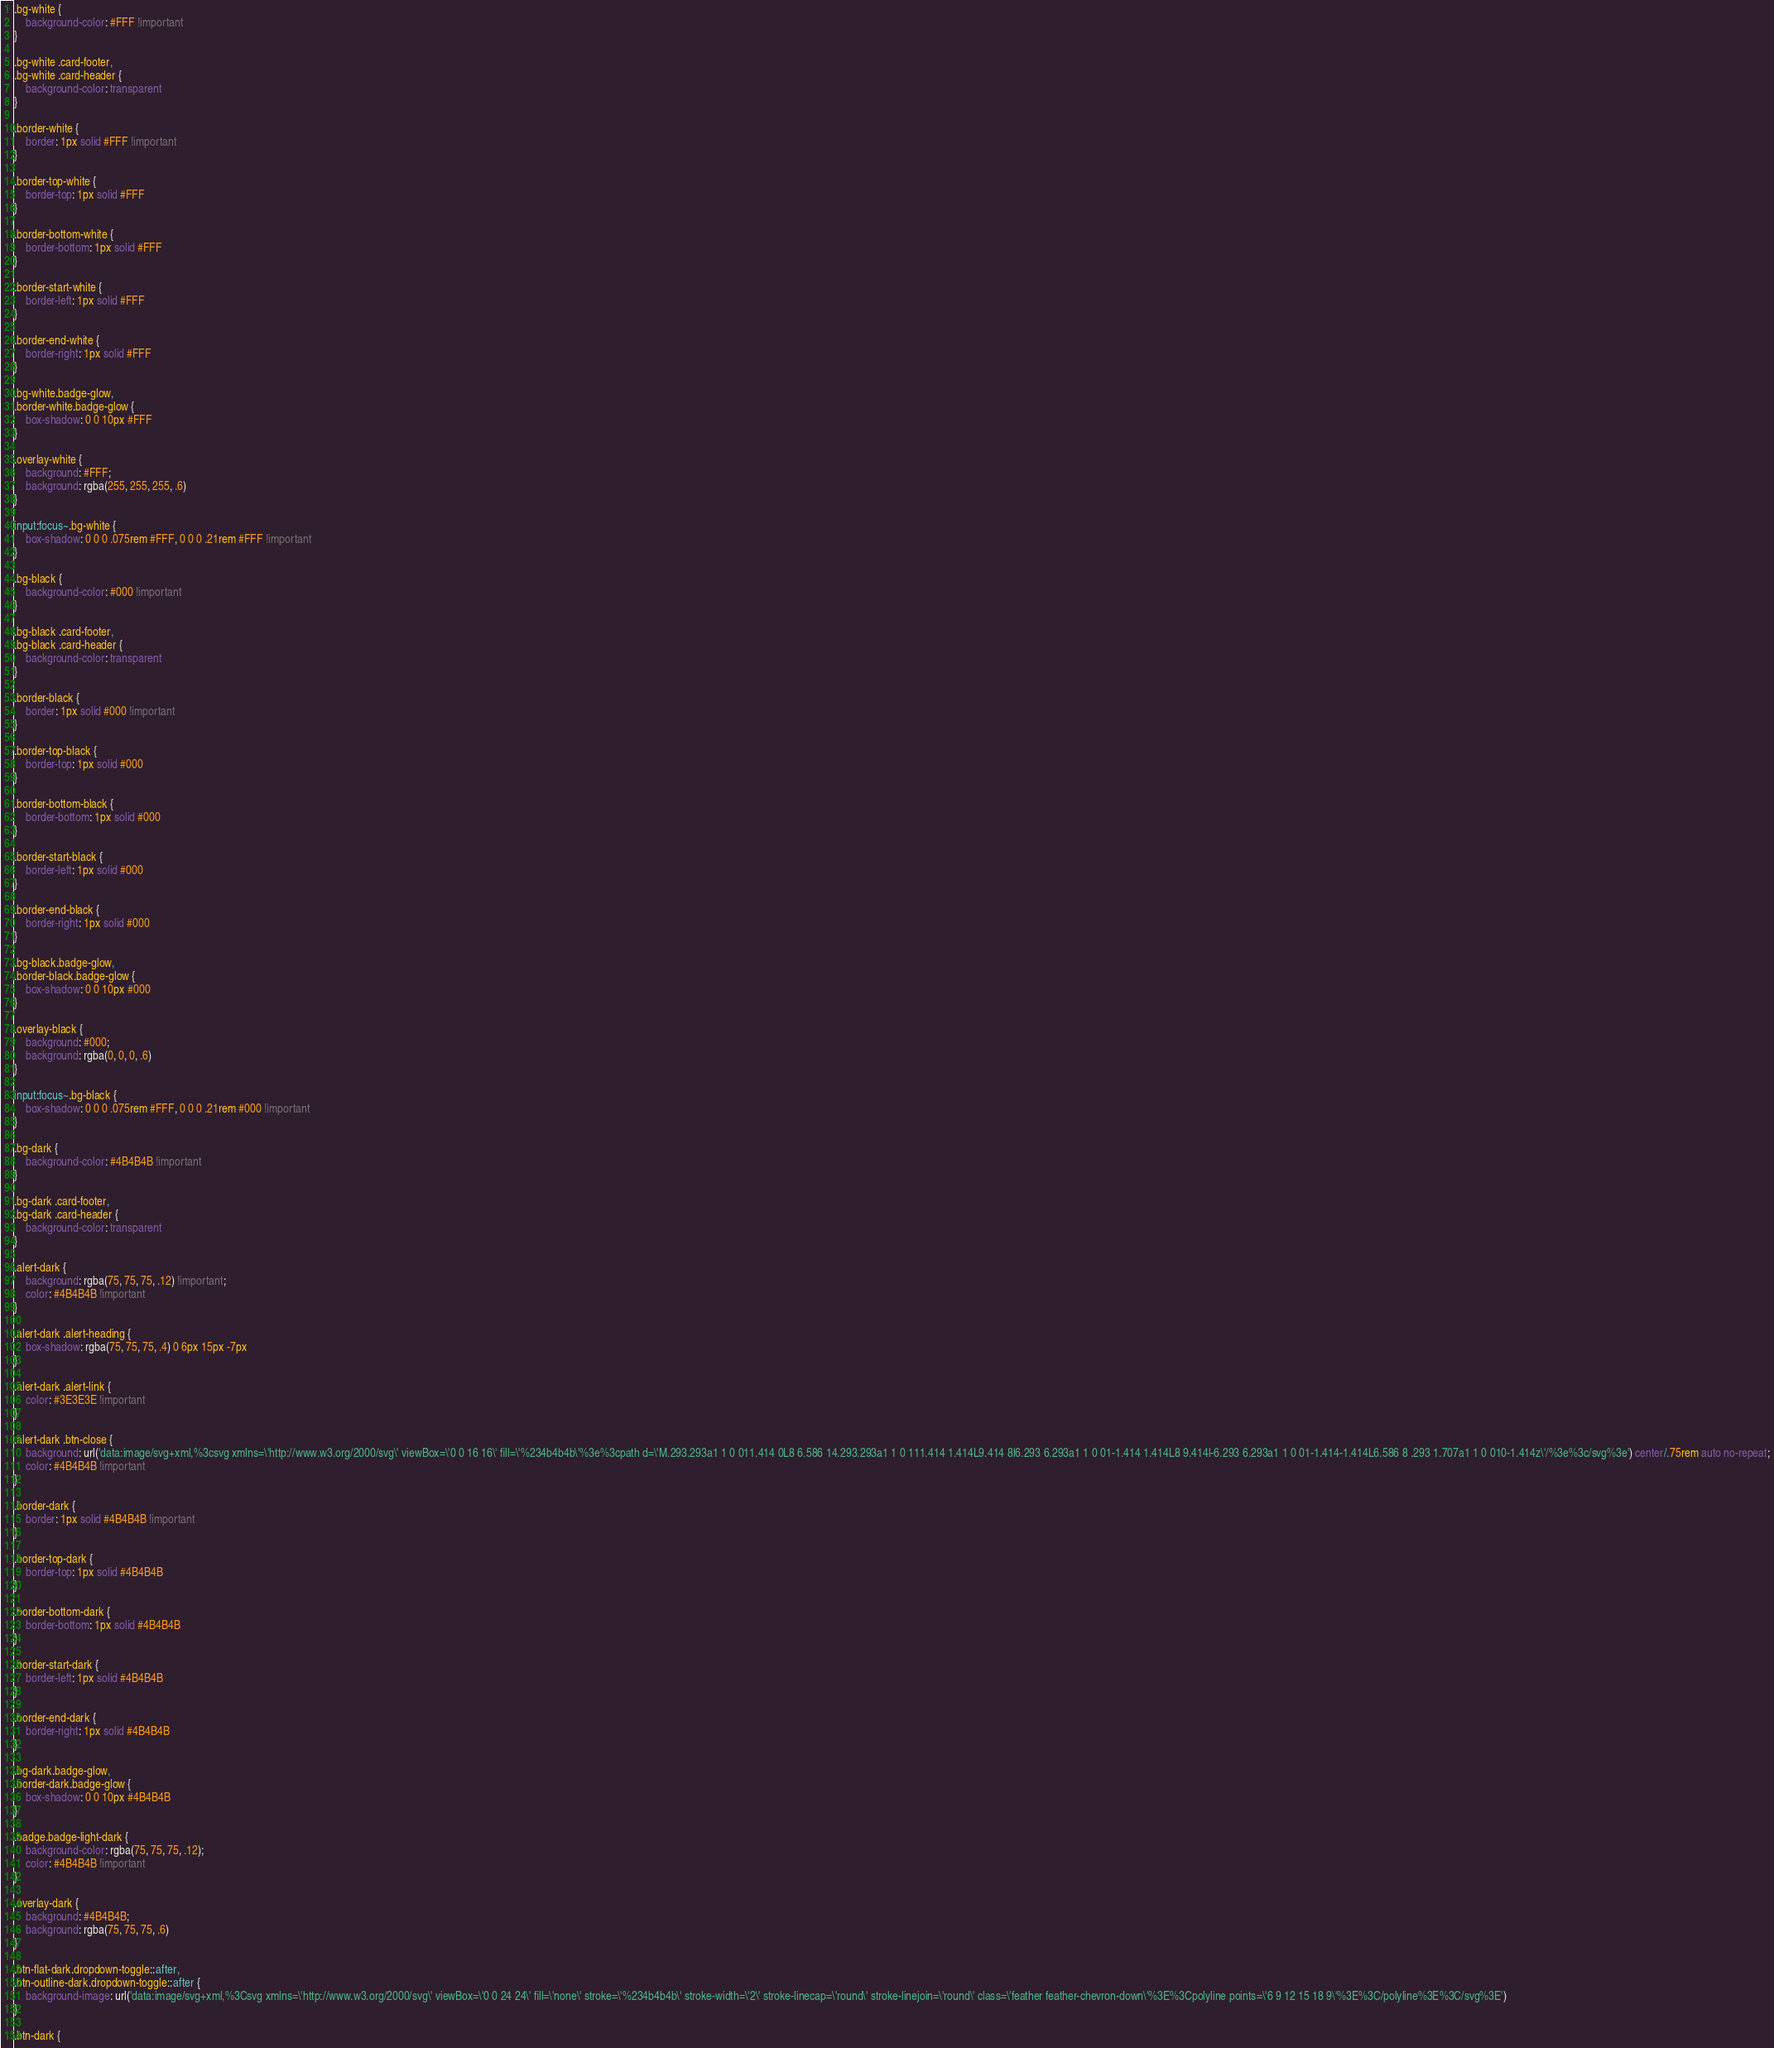Convert code to text. <code><loc_0><loc_0><loc_500><loc_500><_CSS_>.bg-white {
    background-color: #FFF !important
}

.bg-white .card-footer,
.bg-white .card-header {
    background-color: transparent
}

.border-white {
    border: 1px solid #FFF !important
}

.border-top-white {
    border-top: 1px solid #FFF
}

.border-bottom-white {
    border-bottom: 1px solid #FFF
}

.border-start-white {
    border-left: 1px solid #FFF
}

.border-end-white {
    border-right: 1px solid #FFF
}

.bg-white.badge-glow,
.border-white.badge-glow {
    box-shadow: 0 0 10px #FFF
}

.overlay-white {
    background: #FFF;
    background: rgba(255, 255, 255, .6)
}

input:focus~.bg-white {
    box-shadow: 0 0 0 .075rem #FFF, 0 0 0 .21rem #FFF !important
}

.bg-black {
    background-color: #000 !important
}

.bg-black .card-footer,
.bg-black .card-header {
    background-color: transparent
}

.border-black {
    border: 1px solid #000 !important
}

.border-top-black {
    border-top: 1px solid #000
}

.border-bottom-black {
    border-bottom: 1px solid #000
}

.border-start-black {
    border-left: 1px solid #000
}

.border-end-black {
    border-right: 1px solid #000
}

.bg-black.badge-glow,
.border-black.badge-glow {
    box-shadow: 0 0 10px #000
}

.overlay-black {
    background: #000;
    background: rgba(0, 0, 0, .6)
}

input:focus~.bg-black {
    box-shadow: 0 0 0 .075rem #FFF, 0 0 0 .21rem #000 !important
}

.bg-dark {
    background-color: #4B4B4B !important
}

.bg-dark .card-footer,
.bg-dark .card-header {
    background-color: transparent
}

.alert-dark {
    background: rgba(75, 75, 75, .12) !important;
    color: #4B4B4B !important
}

.alert-dark .alert-heading {
    box-shadow: rgba(75, 75, 75, .4) 0 6px 15px -7px
}

.alert-dark .alert-link {
    color: #3E3E3E !important
}

.alert-dark .btn-close {
    background: url('data:image/svg+xml,%3csvg xmlns=\'http://www.w3.org/2000/svg\' viewBox=\'0 0 16 16\' fill=\'%234b4b4b\'%3e%3cpath d=\'M.293.293a1 1 0 011.414 0L8 6.586 14.293.293a1 1 0 111.414 1.414L9.414 8l6.293 6.293a1 1 0 01-1.414 1.414L8 9.414l-6.293 6.293a1 1 0 01-1.414-1.414L6.586 8 .293 1.707a1 1 0 010-1.414z\'/%3e%3c/svg%3e') center/.75rem auto no-repeat;
    color: #4B4B4B !important
}

.border-dark {
    border: 1px solid #4B4B4B !important
}

.border-top-dark {
    border-top: 1px solid #4B4B4B
}

.border-bottom-dark {
    border-bottom: 1px solid #4B4B4B
}

.border-start-dark {
    border-left: 1px solid #4B4B4B
}

.border-end-dark {
    border-right: 1px solid #4B4B4B
}

.bg-dark.badge-glow,
.border-dark.badge-glow {
    box-shadow: 0 0 10px #4B4B4B
}

.badge.badge-light-dark {
    background-color: rgba(75, 75, 75, .12);
    color: #4B4B4B !important
}

.overlay-dark {
    background: #4B4B4B;
    background: rgba(75, 75, 75, .6)
}

.btn-flat-dark.dropdown-toggle::after,
.btn-outline-dark.dropdown-toggle::after {
    background-image: url('data:image/svg+xml,%3Csvg xmlns=\'http://www.w3.org/2000/svg\' viewBox=\'0 0 24 24\' fill=\'none\' stroke=\'%234b4b4b\' stroke-width=\'2\' stroke-linecap=\'round\' stroke-linejoin=\'round\' class=\'feather feather-chevron-down\'%3E%3Cpolyline points=\'6 9 12 15 18 9\'%3E%3C/polyline%3E%3C/svg%3E')
}

.btn-dark {</code> 